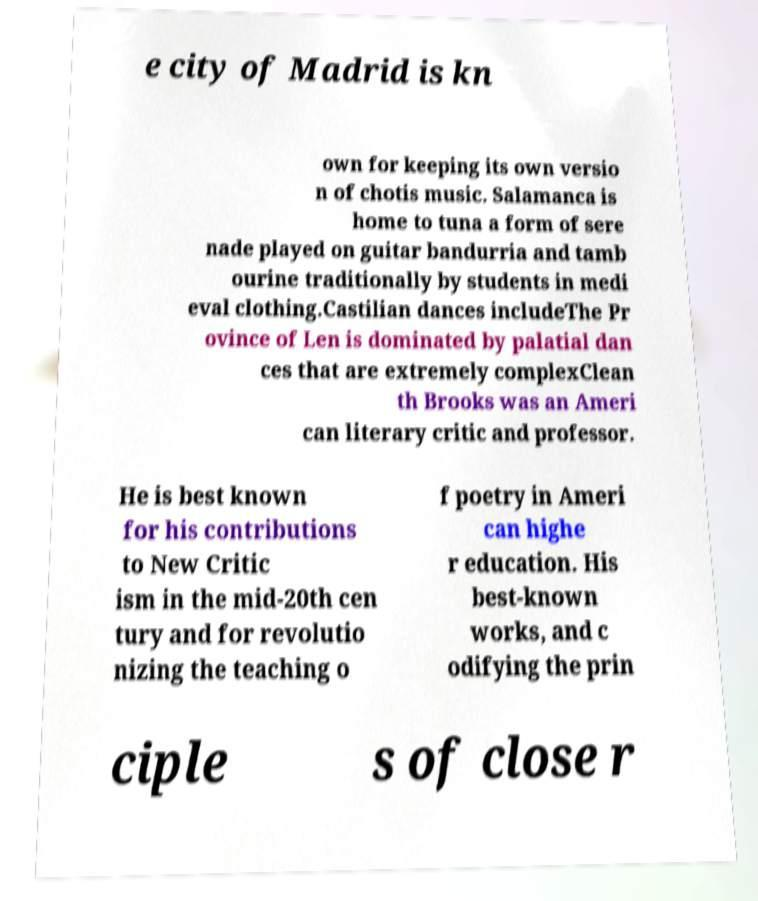Please identify and transcribe the text found in this image. e city of Madrid is kn own for keeping its own versio n of chotis music. Salamanca is home to tuna a form of sere nade played on guitar bandurria and tamb ourine traditionally by students in medi eval clothing.Castilian dances includeThe Pr ovince of Len is dominated by palatial dan ces that are extremely complexClean th Brooks was an Ameri can literary critic and professor. He is best known for his contributions to New Critic ism in the mid-20th cen tury and for revolutio nizing the teaching o f poetry in Ameri can highe r education. His best-known works, and c odifying the prin ciple s of close r 